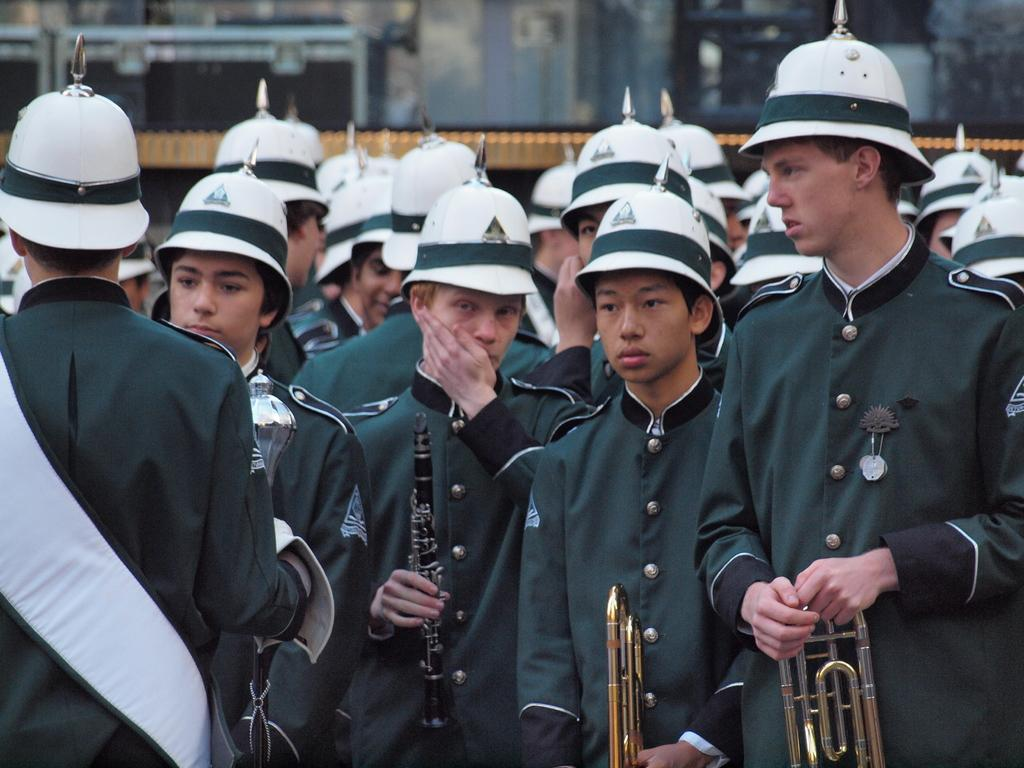How many people are in the image? There are many people in the image. What are the people wearing on their heads? The people are wearing white and green caps. What are the people wearing that is similar? The people are wearing the same uniform. What are the people holding in their hands? The people are holding different musical instruments. Can you hear the sound of bells in the image? There is no sound present in the image, so it is not possible to hear the sound of bells. 